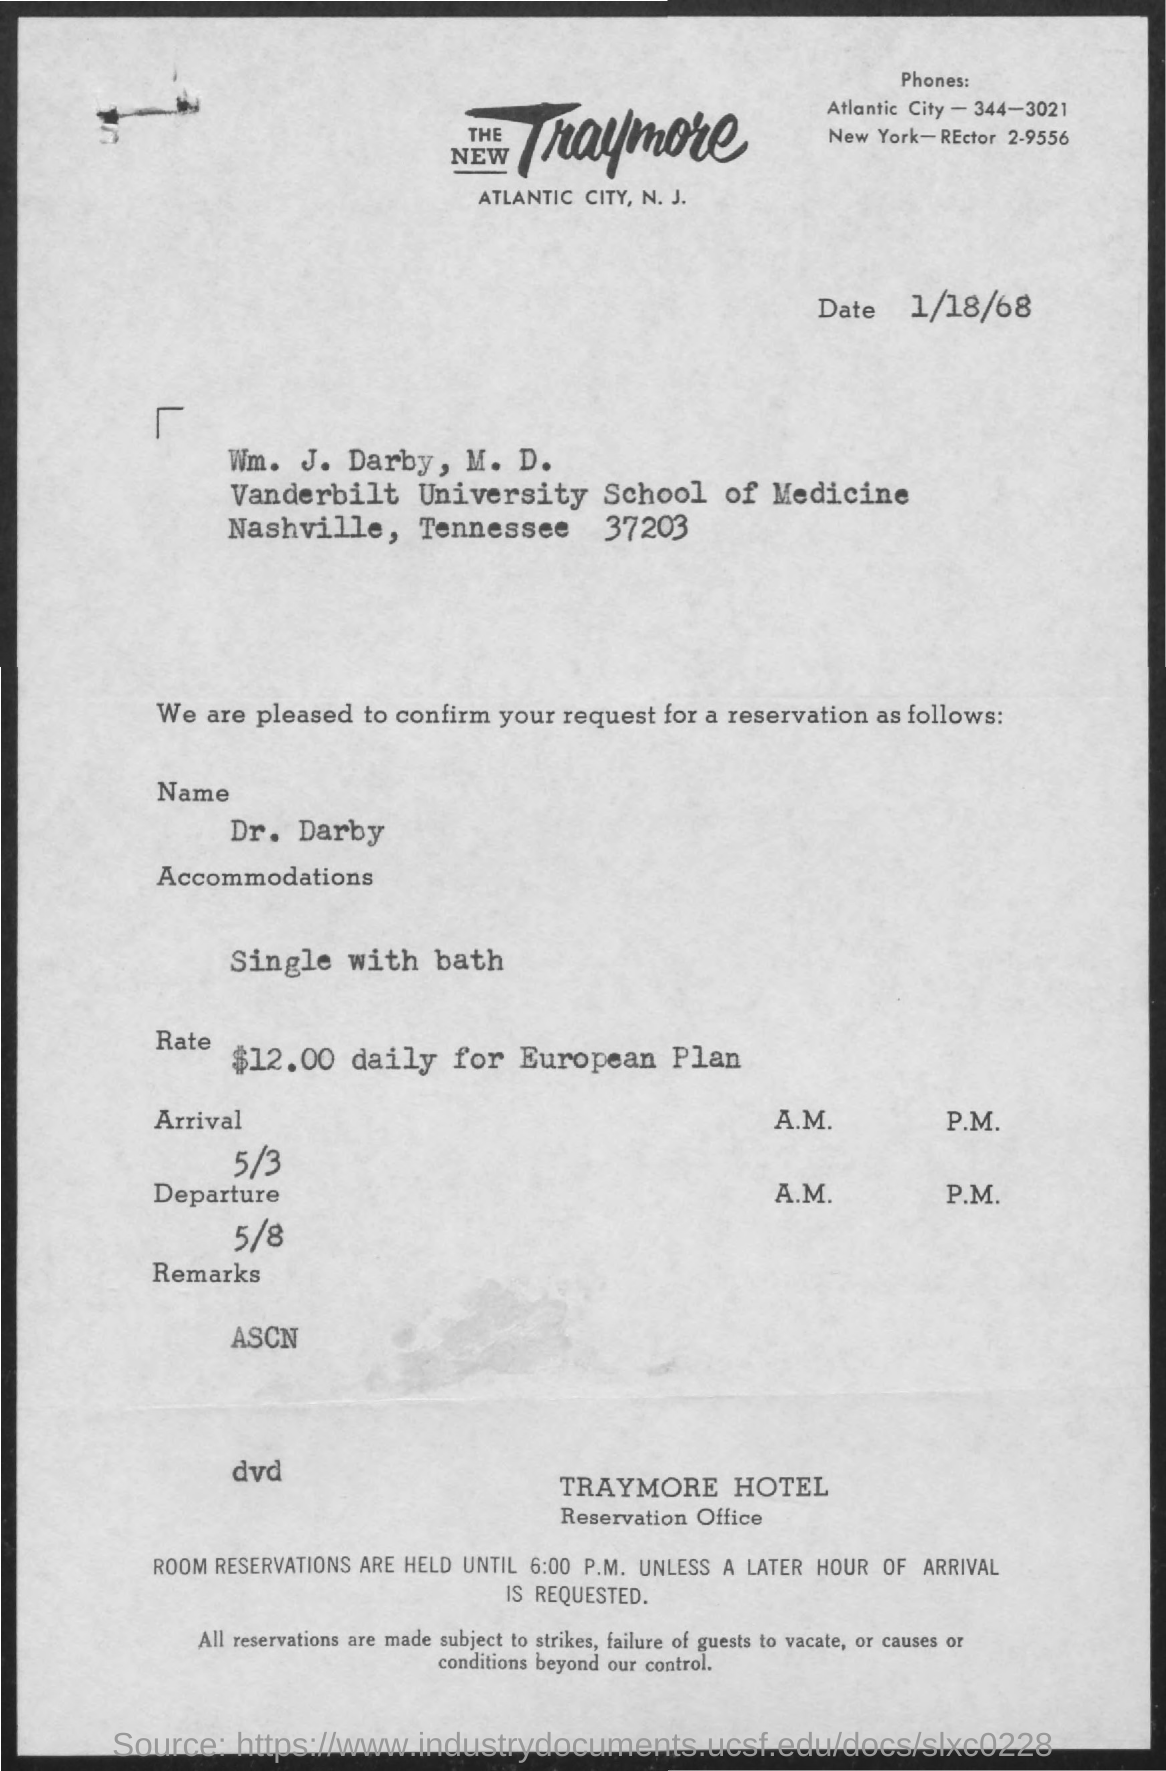What is the phone number of Atlantic City?
Provide a succinct answer. 344-3021. What is the date mentioned at the top of the document?
Your response must be concise. 1/18/68. What is the name of the person who reserved the room?
Give a very brief answer. Dr. darby. Which type of room Dr. Darby booked?
Provide a short and direct response. Single with bath. 